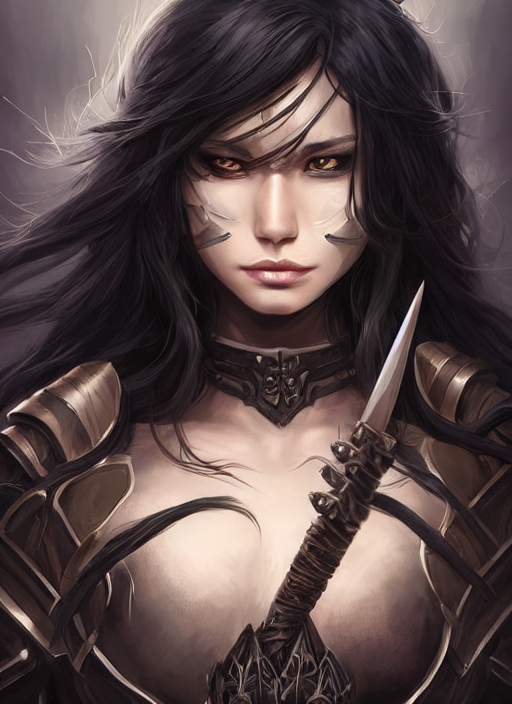Does the weapon hold any significance in relation to the character's identity or story? While the specific story behind the character is not clear from the image alone, the weapon—a sleek dagger with a detailed hilt—suggests it may be a signature piece or hold sentimental value. It could represent the character's personal fighting style, which may favor agility and precision over brute strength, or it could be an heirloom or a token from a significant event in their story. 